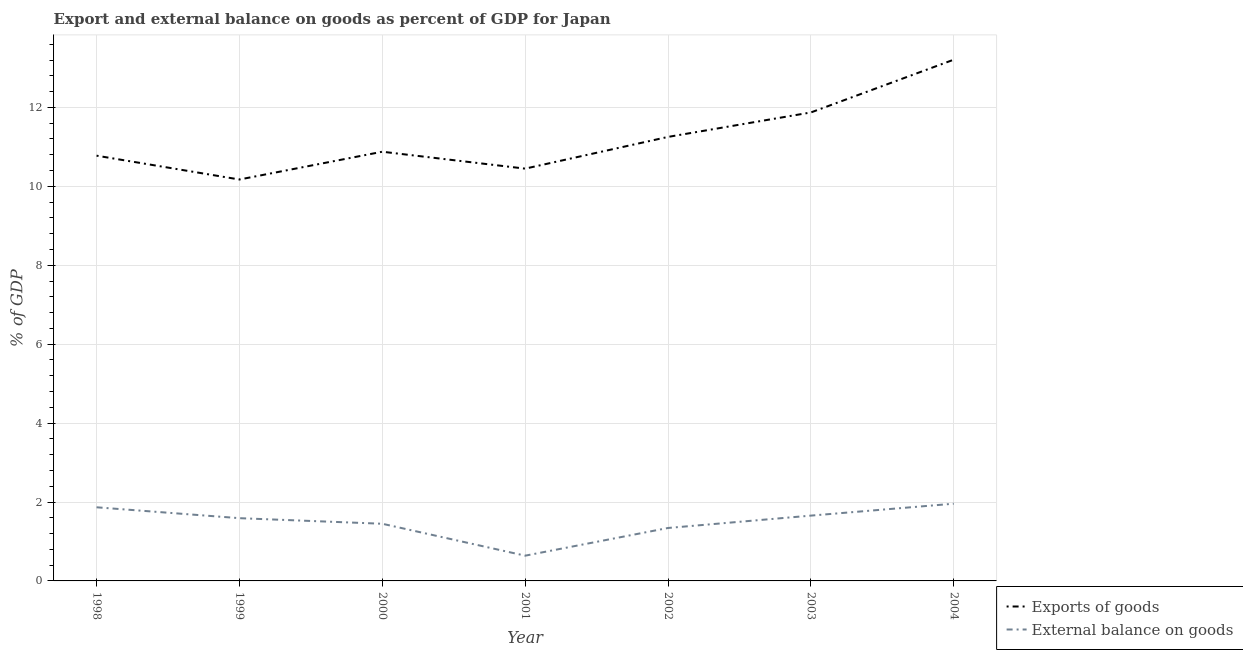How many different coloured lines are there?
Give a very brief answer. 2. Is the number of lines equal to the number of legend labels?
Make the answer very short. Yes. What is the external balance on goods as percentage of gdp in 2000?
Offer a terse response. 1.45. Across all years, what is the maximum external balance on goods as percentage of gdp?
Your response must be concise. 1.96. Across all years, what is the minimum export of goods as percentage of gdp?
Your answer should be very brief. 10.17. In which year was the external balance on goods as percentage of gdp minimum?
Provide a short and direct response. 2001. What is the total export of goods as percentage of gdp in the graph?
Offer a very short reply. 78.61. What is the difference between the external balance on goods as percentage of gdp in 2000 and that in 2001?
Offer a terse response. 0.81. What is the difference between the export of goods as percentage of gdp in 2004 and the external balance on goods as percentage of gdp in 2003?
Your answer should be compact. 11.56. What is the average external balance on goods as percentage of gdp per year?
Your response must be concise. 1.5. In the year 2003, what is the difference between the external balance on goods as percentage of gdp and export of goods as percentage of gdp?
Your answer should be compact. -10.22. What is the ratio of the external balance on goods as percentage of gdp in 2003 to that in 2004?
Provide a succinct answer. 0.85. Is the difference between the external balance on goods as percentage of gdp in 1999 and 2001 greater than the difference between the export of goods as percentage of gdp in 1999 and 2001?
Ensure brevity in your answer.  Yes. What is the difference between the highest and the second highest external balance on goods as percentage of gdp?
Provide a succinct answer. 0.09. What is the difference between the highest and the lowest export of goods as percentage of gdp?
Your response must be concise. 3.04. In how many years, is the external balance on goods as percentage of gdp greater than the average external balance on goods as percentage of gdp taken over all years?
Ensure brevity in your answer.  4. Is the sum of the external balance on goods as percentage of gdp in 2002 and 2004 greater than the maximum export of goods as percentage of gdp across all years?
Your answer should be compact. No. Is the export of goods as percentage of gdp strictly less than the external balance on goods as percentage of gdp over the years?
Your answer should be very brief. No. How many lines are there?
Your response must be concise. 2. How many years are there in the graph?
Your response must be concise. 7. Does the graph contain any zero values?
Offer a terse response. No. How are the legend labels stacked?
Your response must be concise. Vertical. What is the title of the graph?
Provide a succinct answer. Export and external balance on goods as percent of GDP for Japan. What is the label or title of the Y-axis?
Offer a terse response. % of GDP. What is the % of GDP of Exports of goods in 1998?
Ensure brevity in your answer.  10.78. What is the % of GDP in External balance on goods in 1998?
Provide a succinct answer. 1.87. What is the % of GDP in Exports of goods in 1999?
Your answer should be compact. 10.17. What is the % of GDP in External balance on goods in 1999?
Your response must be concise. 1.59. What is the % of GDP of Exports of goods in 2000?
Make the answer very short. 10.88. What is the % of GDP in External balance on goods in 2000?
Provide a short and direct response. 1.45. What is the % of GDP in Exports of goods in 2001?
Your answer should be very brief. 10.45. What is the % of GDP of External balance on goods in 2001?
Ensure brevity in your answer.  0.64. What is the % of GDP in Exports of goods in 2002?
Keep it short and to the point. 11.25. What is the % of GDP in External balance on goods in 2002?
Offer a terse response. 1.34. What is the % of GDP in Exports of goods in 2003?
Your answer should be compact. 11.87. What is the % of GDP in External balance on goods in 2003?
Offer a terse response. 1.66. What is the % of GDP of Exports of goods in 2004?
Provide a short and direct response. 13.21. What is the % of GDP of External balance on goods in 2004?
Make the answer very short. 1.96. Across all years, what is the maximum % of GDP of Exports of goods?
Your answer should be compact. 13.21. Across all years, what is the maximum % of GDP of External balance on goods?
Provide a short and direct response. 1.96. Across all years, what is the minimum % of GDP of Exports of goods?
Offer a terse response. 10.17. Across all years, what is the minimum % of GDP of External balance on goods?
Offer a very short reply. 0.64. What is the total % of GDP in Exports of goods in the graph?
Your answer should be compact. 78.61. What is the total % of GDP in External balance on goods in the graph?
Make the answer very short. 10.5. What is the difference between the % of GDP of Exports of goods in 1998 and that in 1999?
Your answer should be very brief. 0.6. What is the difference between the % of GDP of External balance on goods in 1998 and that in 1999?
Offer a very short reply. 0.28. What is the difference between the % of GDP in Exports of goods in 1998 and that in 2000?
Your answer should be very brief. -0.1. What is the difference between the % of GDP of External balance on goods in 1998 and that in 2000?
Provide a short and direct response. 0.42. What is the difference between the % of GDP of Exports of goods in 1998 and that in 2001?
Give a very brief answer. 0.33. What is the difference between the % of GDP in External balance on goods in 1998 and that in 2001?
Offer a very short reply. 1.23. What is the difference between the % of GDP of Exports of goods in 1998 and that in 2002?
Your answer should be compact. -0.48. What is the difference between the % of GDP of External balance on goods in 1998 and that in 2002?
Offer a terse response. 0.52. What is the difference between the % of GDP of Exports of goods in 1998 and that in 2003?
Your response must be concise. -1.1. What is the difference between the % of GDP in External balance on goods in 1998 and that in 2003?
Your answer should be compact. 0.21. What is the difference between the % of GDP of Exports of goods in 1998 and that in 2004?
Make the answer very short. -2.43. What is the difference between the % of GDP of External balance on goods in 1998 and that in 2004?
Give a very brief answer. -0.09. What is the difference between the % of GDP of Exports of goods in 1999 and that in 2000?
Provide a succinct answer. -0.7. What is the difference between the % of GDP of External balance on goods in 1999 and that in 2000?
Ensure brevity in your answer.  0.14. What is the difference between the % of GDP of Exports of goods in 1999 and that in 2001?
Provide a short and direct response. -0.28. What is the difference between the % of GDP in External balance on goods in 1999 and that in 2001?
Your answer should be compact. 0.95. What is the difference between the % of GDP in Exports of goods in 1999 and that in 2002?
Your answer should be compact. -1.08. What is the difference between the % of GDP of External balance on goods in 1999 and that in 2002?
Keep it short and to the point. 0.25. What is the difference between the % of GDP in Exports of goods in 1999 and that in 2003?
Provide a short and direct response. -1.7. What is the difference between the % of GDP of External balance on goods in 1999 and that in 2003?
Keep it short and to the point. -0.06. What is the difference between the % of GDP of Exports of goods in 1999 and that in 2004?
Provide a short and direct response. -3.04. What is the difference between the % of GDP in External balance on goods in 1999 and that in 2004?
Give a very brief answer. -0.37. What is the difference between the % of GDP of Exports of goods in 2000 and that in 2001?
Make the answer very short. 0.43. What is the difference between the % of GDP of External balance on goods in 2000 and that in 2001?
Your response must be concise. 0.81. What is the difference between the % of GDP in Exports of goods in 2000 and that in 2002?
Provide a short and direct response. -0.38. What is the difference between the % of GDP of External balance on goods in 2000 and that in 2002?
Provide a short and direct response. 0.11. What is the difference between the % of GDP of Exports of goods in 2000 and that in 2003?
Offer a very short reply. -1. What is the difference between the % of GDP in External balance on goods in 2000 and that in 2003?
Offer a very short reply. -0.21. What is the difference between the % of GDP of Exports of goods in 2000 and that in 2004?
Your response must be concise. -2.33. What is the difference between the % of GDP in External balance on goods in 2000 and that in 2004?
Provide a succinct answer. -0.51. What is the difference between the % of GDP of Exports of goods in 2001 and that in 2002?
Offer a very short reply. -0.8. What is the difference between the % of GDP in External balance on goods in 2001 and that in 2002?
Provide a succinct answer. -0.7. What is the difference between the % of GDP of Exports of goods in 2001 and that in 2003?
Provide a succinct answer. -1.42. What is the difference between the % of GDP in External balance on goods in 2001 and that in 2003?
Provide a succinct answer. -1.02. What is the difference between the % of GDP in Exports of goods in 2001 and that in 2004?
Make the answer very short. -2.76. What is the difference between the % of GDP of External balance on goods in 2001 and that in 2004?
Provide a succinct answer. -1.32. What is the difference between the % of GDP in Exports of goods in 2002 and that in 2003?
Give a very brief answer. -0.62. What is the difference between the % of GDP in External balance on goods in 2002 and that in 2003?
Offer a terse response. -0.31. What is the difference between the % of GDP of Exports of goods in 2002 and that in 2004?
Your answer should be very brief. -1.96. What is the difference between the % of GDP of External balance on goods in 2002 and that in 2004?
Offer a very short reply. -0.62. What is the difference between the % of GDP in Exports of goods in 2003 and that in 2004?
Provide a short and direct response. -1.34. What is the difference between the % of GDP of External balance on goods in 2003 and that in 2004?
Your answer should be compact. -0.3. What is the difference between the % of GDP in Exports of goods in 1998 and the % of GDP in External balance on goods in 1999?
Offer a terse response. 9.19. What is the difference between the % of GDP of Exports of goods in 1998 and the % of GDP of External balance on goods in 2000?
Provide a succinct answer. 9.33. What is the difference between the % of GDP in Exports of goods in 1998 and the % of GDP in External balance on goods in 2001?
Keep it short and to the point. 10.14. What is the difference between the % of GDP in Exports of goods in 1998 and the % of GDP in External balance on goods in 2002?
Offer a very short reply. 9.44. What is the difference between the % of GDP in Exports of goods in 1998 and the % of GDP in External balance on goods in 2003?
Your answer should be compact. 9.12. What is the difference between the % of GDP of Exports of goods in 1998 and the % of GDP of External balance on goods in 2004?
Ensure brevity in your answer.  8.82. What is the difference between the % of GDP of Exports of goods in 1999 and the % of GDP of External balance on goods in 2000?
Keep it short and to the point. 8.72. What is the difference between the % of GDP of Exports of goods in 1999 and the % of GDP of External balance on goods in 2001?
Keep it short and to the point. 9.53. What is the difference between the % of GDP in Exports of goods in 1999 and the % of GDP in External balance on goods in 2002?
Your answer should be compact. 8.83. What is the difference between the % of GDP of Exports of goods in 1999 and the % of GDP of External balance on goods in 2003?
Your response must be concise. 8.52. What is the difference between the % of GDP in Exports of goods in 1999 and the % of GDP in External balance on goods in 2004?
Keep it short and to the point. 8.22. What is the difference between the % of GDP in Exports of goods in 2000 and the % of GDP in External balance on goods in 2001?
Offer a very short reply. 10.24. What is the difference between the % of GDP in Exports of goods in 2000 and the % of GDP in External balance on goods in 2002?
Provide a succinct answer. 9.54. What is the difference between the % of GDP of Exports of goods in 2000 and the % of GDP of External balance on goods in 2003?
Your answer should be very brief. 9.22. What is the difference between the % of GDP in Exports of goods in 2000 and the % of GDP in External balance on goods in 2004?
Keep it short and to the point. 8.92. What is the difference between the % of GDP of Exports of goods in 2001 and the % of GDP of External balance on goods in 2002?
Your answer should be very brief. 9.11. What is the difference between the % of GDP in Exports of goods in 2001 and the % of GDP in External balance on goods in 2003?
Ensure brevity in your answer.  8.79. What is the difference between the % of GDP of Exports of goods in 2001 and the % of GDP of External balance on goods in 2004?
Make the answer very short. 8.49. What is the difference between the % of GDP in Exports of goods in 2002 and the % of GDP in External balance on goods in 2003?
Your answer should be very brief. 9.6. What is the difference between the % of GDP of Exports of goods in 2002 and the % of GDP of External balance on goods in 2004?
Make the answer very short. 9.3. What is the difference between the % of GDP in Exports of goods in 2003 and the % of GDP in External balance on goods in 2004?
Offer a very short reply. 9.92. What is the average % of GDP in Exports of goods per year?
Your answer should be compact. 11.23. What is the average % of GDP of External balance on goods per year?
Your answer should be compact. 1.5. In the year 1998, what is the difference between the % of GDP of Exports of goods and % of GDP of External balance on goods?
Offer a very short reply. 8.91. In the year 1999, what is the difference between the % of GDP of Exports of goods and % of GDP of External balance on goods?
Offer a very short reply. 8.58. In the year 2000, what is the difference between the % of GDP in Exports of goods and % of GDP in External balance on goods?
Ensure brevity in your answer.  9.43. In the year 2001, what is the difference between the % of GDP in Exports of goods and % of GDP in External balance on goods?
Provide a succinct answer. 9.81. In the year 2002, what is the difference between the % of GDP of Exports of goods and % of GDP of External balance on goods?
Keep it short and to the point. 9.91. In the year 2003, what is the difference between the % of GDP in Exports of goods and % of GDP in External balance on goods?
Provide a succinct answer. 10.22. In the year 2004, what is the difference between the % of GDP in Exports of goods and % of GDP in External balance on goods?
Your answer should be compact. 11.25. What is the ratio of the % of GDP of Exports of goods in 1998 to that in 1999?
Keep it short and to the point. 1.06. What is the ratio of the % of GDP of External balance on goods in 1998 to that in 1999?
Offer a very short reply. 1.17. What is the ratio of the % of GDP of Exports of goods in 1998 to that in 2000?
Your answer should be very brief. 0.99. What is the ratio of the % of GDP of External balance on goods in 1998 to that in 2000?
Offer a terse response. 1.29. What is the ratio of the % of GDP in Exports of goods in 1998 to that in 2001?
Your answer should be very brief. 1.03. What is the ratio of the % of GDP in External balance on goods in 1998 to that in 2001?
Your response must be concise. 2.92. What is the ratio of the % of GDP in Exports of goods in 1998 to that in 2002?
Provide a short and direct response. 0.96. What is the ratio of the % of GDP in External balance on goods in 1998 to that in 2002?
Provide a short and direct response. 1.39. What is the ratio of the % of GDP in Exports of goods in 1998 to that in 2003?
Provide a succinct answer. 0.91. What is the ratio of the % of GDP in External balance on goods in 1998 to that in 2003?
Offer a terse response. 1.13. What is the ratio of the % of GDP of Exports of goods in 1998 to that in 2004?
Give a very brief answer. 0.82. What is the ratio of the % of GDP in External balance on goods in 1998 to that in 2004?
Provide a succinct answer. 0.95. What is the ratio of the % of GDP in Exports of goods in 1999 to that in 2000?
Give a very brief answer. 0.94. What is the ratio of the % of GDP of External balance on goods in 1999 to that in 2000?
Provide a short and direct response. 1.1. What is the ratio of the % of GDP in Exports of goods in 1999 to that in 2001?
Ensure brevity in your answer.  0.97. What is the ratio of the % of GDP of External balance on goods in 1999 to that in 2001?
Make the answer very short. 2.49. What is the ratio of the % of GDP in Exports of goods in 1999 to that in 2002?
Keep it short and to the point. 0.9. What is the ratio of the % of GDP in External balance on goods in 1999 to that in 2002?
Offer a very short reply. 1.19. What is the ratio of the % of GDP in Exports of goods in 1999 to that in 2003?
Provide a succinct answer. 0.86. What is the ratio of the % of GDP in External balance on goods in 1999 to that in 2003?
Ensure brevity in your answer.  0.96. What is the ratio of the % of GDP of Exports of goods in 1999 to that in 2004?
Your answer should be compact. 0.77. What is the ratio of the % of GDP of External balance on goods in 1999 to that in 2004?
Offer a terse response. 0.81. What is the ratio of the % of GDP of Exports of goods in 2000 to that in 2001?
Keep it short and to the point. 1.04. What is the ratio of the % of GDP in External balance on goods in 2000 to that in 2001?
Make the answer very short. 2.26. What is the ratio of the % of GDP of Exports of goods in 2000 to that in 2002?
Offer a very short reply. 0.97. What is the ratio of the % of GDP of External balance on goods in 2000 to that in 2002?
Provide a succinct answer. 1.08. What is the ratio of the % of GDP of Exports of goods in 2000 to that in 2003?
Offer a very short reply. 0.92. What is the ratio of the % of GDP in External balance on goods in 2000 to that in 2003?
Your answer should be very brief. 0.88. What is the ratio of the % of GDP in Exports of goods in 2000 to that in 2004?
Offer a very short reply. 0.82. What is the ratio of the % of GDP of External balance on goods in 2000 to that in 2004?
Offer a very short reply. 0.74. What is the ratio of the % of GDP in Exports of goods in 2001 to that in 2002?
Offer a very short reply. 0.93. What is the ratio of the % of GDP in External balance on goods in 2001 to that in 2002?
Ensure brevity in your answer.  0.48. What is the ratio of the % of GDP in Exports of goods in 2001 to that in 2003?
Provide a short and direct response. 0.88. What is the ratio of the % of GDP in External balance on goods in 2001 to that in 2003?
Provide a succinct answer. 0.39. What is the ratio of the % of GDP of Exports of goods in 2001 to that in 2004?
Provide a succinct answer. 0.79. What is the ratio of the % of GDP in External balance on goods in 2001 to that in 2004?
Provide a succinct answer. 0.33. What is the ratio of the % of GDP of Exports of goods in 2002 to that in 2003?
Offer a very short reply. 0.95. What is the ratio of the % of GDP in External balance on goods in 2002 to that in 2003?
Ensure brevity in your answer.  0.81. What is the ratio of the % of GDP of Exports of goods in 2002 to that in 2004?
Your response must be concise. 0.85. What is the ratio of the % of GDP of External balance on goods in 2002 to that in 2004?
Offer a terse response. 0.69. What is the ratio of the % of GDP in Exports of goods in 2003 to that in 2004?
Provide a short and direct response. 0.9. What is the ratio of the % of GDP of External balance on goods in 2003 to that in 2004?
Provide a succinct answer. 0.85. What is the difference between the highest and the second highest % of GDP of Exports of goods?
Your answer should be compact. 1.34. What is the difference between the highest and the second highest % of GDP of External balance on goods?
Provide a succinct answer. 0.09. What is the difference between the highest and the lowest % of GDP in Exports of goods?
Make the answer very short. 3.04. What is the difference between the highest and the lowest % of GDP in External balance on goods?
Your response must be concise. 1.32. 